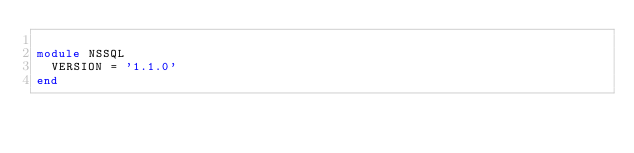<code> <loc_0><loc_0><loc_500><loc_500><_Ruby_>
module NSSQL
  VERSION = '1.1.0'
end
</code> 